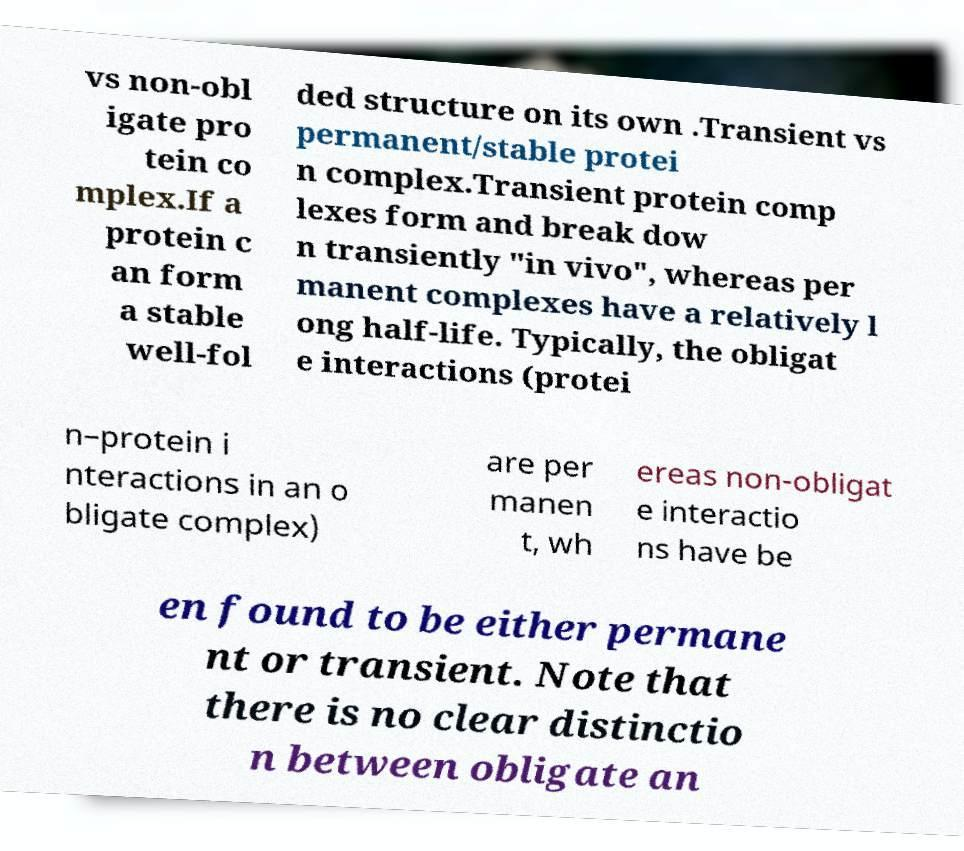For documentation purposes, I need the text within this image transcribed. Could you provide that? vs non-obl igate pro tein co mplex.If a protein c an form a stable well-fol ded structure on its own .Transient vs permanent/stable protei n complex.Transient protein comp lexes form and break dow n transiently "in vivo", whereas per manent complexes have a relatively l ong half-life. Typically, the obligat e interactions (protei n–protein i nteractions in an o bligate complex) are per manen t, wh ereas non-obligat e interactio ns have be en found to be either permane nt or transient. Note that there is no clear distinctio n between obligate an 